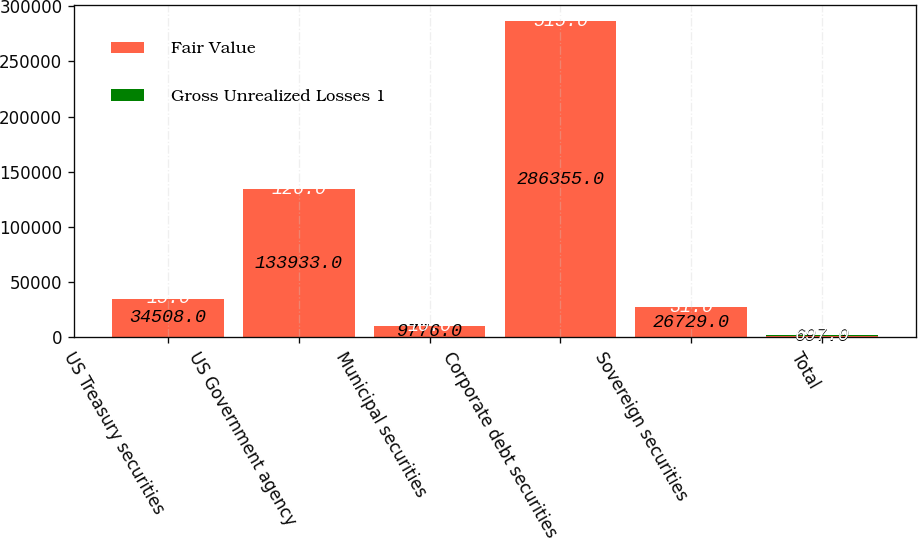Convert chart. <chart><loc_0><loc_0><loc_500><loc_500><stacked_bar_chart><ecel><fcel>US Treasury securities<fcel>US Government agency<fcel>Municipal securities<fcel>Corporate debt securities<fcel>Sovereign securities<fcel>Total<nl><fcel>Fair Value<fcel>34508<fcel>133933<fcel>9776<fcel>286355<fcel>26729<fcel>697<nl><fcel>Gross Unrealized Losses 1<fcel>15<fcel>126<fcel>10<fcel>515<fcel>31<fcel>697<nl></chart> 